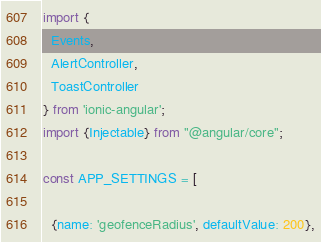Convert code to text. <code><loc_0><loc_0><loc_500><loc_500><_TypeScript_>import {
  Events,
  AlertController,
  ToastController
} from 'ionic-angular';
import {Injectable} from "@angular/core";

const APP_SETTINGS = [

  {name: 'geofenceRadius', defaultValue: 200},</code> 